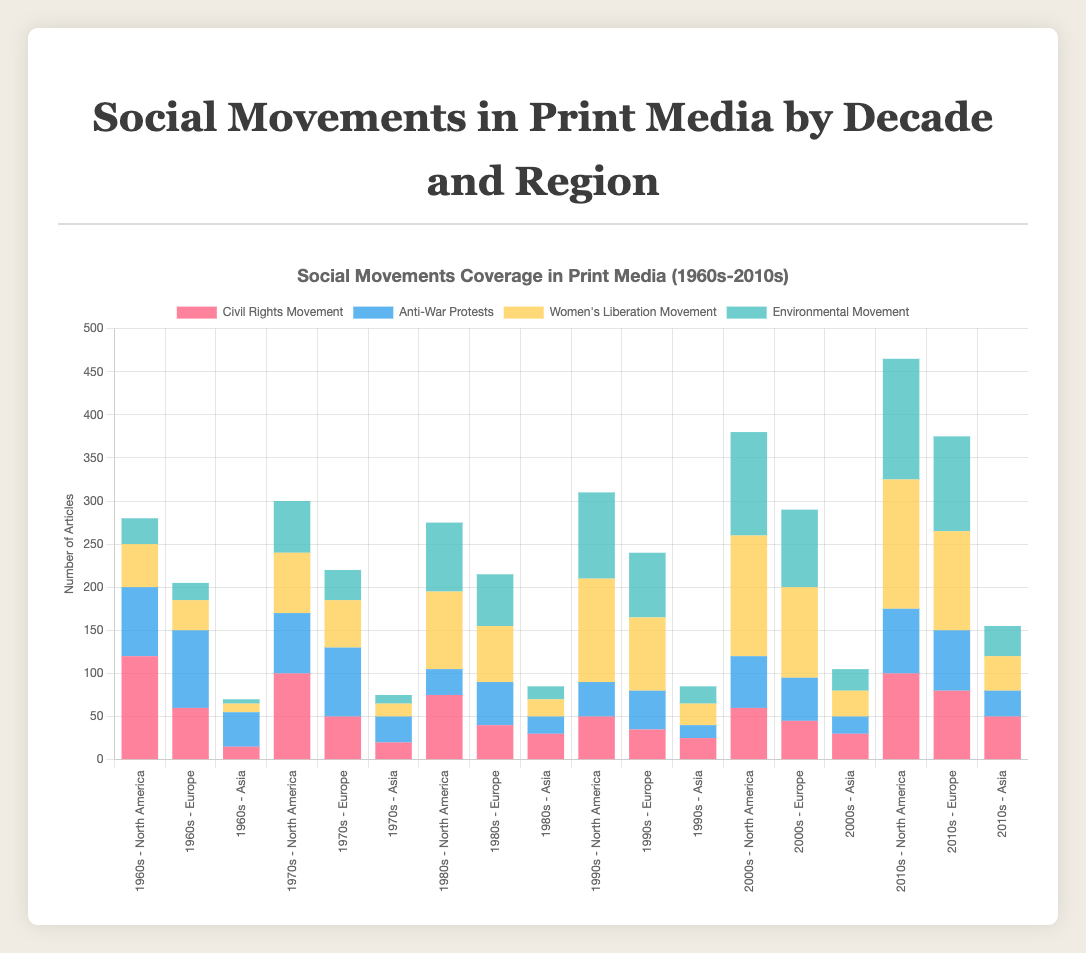What decade and region had the lowest coverage for the Civil Rights Movement? Look at the sections in the stacked bar chart that represent the Civil Rights Movement, identifiable by their specific color. The smallest coverage appears in Asia during the 1960s, where it is about 15 articles.
Answer: 1960s - Asia During the 2010s, which region had the highest coverage for Women's Liberation Movement? Locate all bars representing Women's Liberation Movement in the 2010s. The highest value corresponds to North America with 150 articles.
Answer: North America What is the total coverage for Environmental Movement in Europe across all decades? Sum the Environmental Movement values in Europe for each decade: 20 + 35 + 60 + 75 + 90 + 110 = 390.
Answer: 390 Which movement saw the greatest increase in coverage from the 1960s to the 2010s in North America? Calculate the differences between the 1960s and 2010s for each movement in North America: Civil Rights Movement (100-120)=-20, Anti-War Protests (75-80)=-5, Women's Liberation Movement (150-50)=100, Environmental Movement (140-30)=110. The Environmental Movement saw the greatest increase of +110 articles.
Answer: Environmental Movement Compare the coverage of Anti-War Protests in North America and Europe during the 1970s. Which region had more articles? Look at the bars for the Anti-War Protests in North America and Europe during the 1970s. North America had 70 articles and Europe had 80 articles.
Answer: Europe In which decade did Asia see the highest overall combined coverage for all four movements? Add the values for all movements per decade in Asia: 1960s (15+40+10+5)=70, 1970s (20+30+15+10)=75, 1980s (30+20+20+15)=85, 1990s (25+15+25+20=85), 2000s (30+20+30+25)=105, 2010s (50+30+40+35)=155. The highest combined coverage is in the 2010s with 155 articles.
Answer: 2010s What is the average number of articles for the Women's Liberation Movement in North America from the 1960s to the 2010s? Sum the values for Women's Liberation Movement in North America over the decades: (50+70+90+120+140+150)=620, and divide by the number of decades (6): 620/6=103.33.
Answer: 103.33 Between the 2000s and 2010s, did the coverage for the Anti-War Protests increase or decrease in Europe? Compare the values for Anti-War Protests in Europe between the 2000s (50 articles) and 2010s (70 articles). The coverage increased by 20 articles.
Answer: Increase What movement had uniform or nearly uniform levels of coverage across all regions in the 1980s? Compare the bars for each movement in the 1980s. The Environmental Movement shows relatively uniform bars: North America (80), Europe (60), Asia (15).
Answer: Environmental Movement 